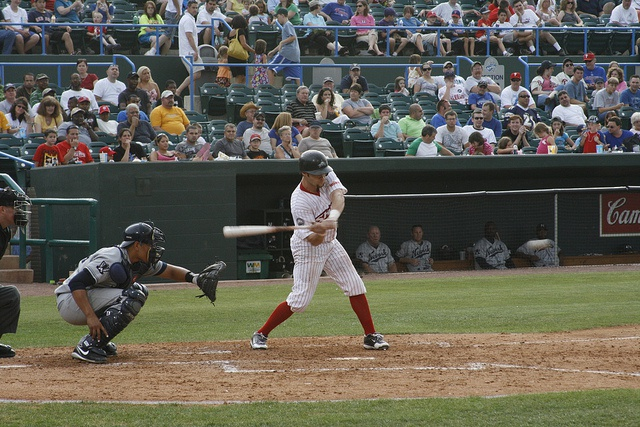Describe the objects in this image and their specific colors. I can see people in black, gray, darkgray, and blue tones, people in black, darkgray, maroon, lightgray, and gray tones, people in black, gray, darkgray, and maroon tones, people in black, gray, and maroon tones, and people in black, gray, and maroon tones in this image. 